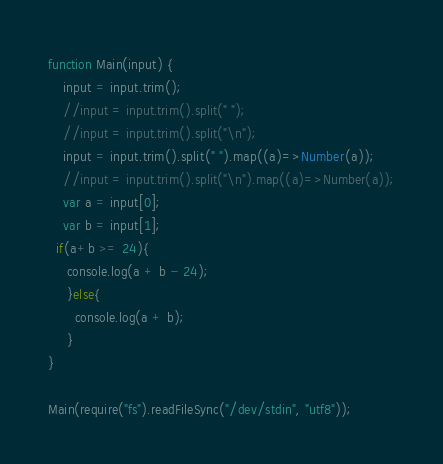<code> <loc_0><loc_0><loc_500><loc_500><_JavaScript_>function Main(input) {
	input = input.trim();
	//input = input.trim().split(" ");
	//input = input.trim().split("\n");
	input = input.trim().split(" ").map((a)=>Number(a));
	//input = input.trim().split("\n").map((a)=>Number(a));
  	var a = input[0];
  	var b = input[1];
  if(a+b >= 24){
     console.log(a + b - 24);
     }else{
       console.log(a + b);
     }
}

Main(require("fs").readFileSync("/dev/stdin", "utf8"));
</code> 